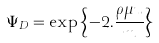<formula> <loc_0><loc_0><loc_500><loc_500>\Psi _ { D } = \exp \left \{ - 2 . \frac { \rho \mu u } { m } \right \}</formula> 